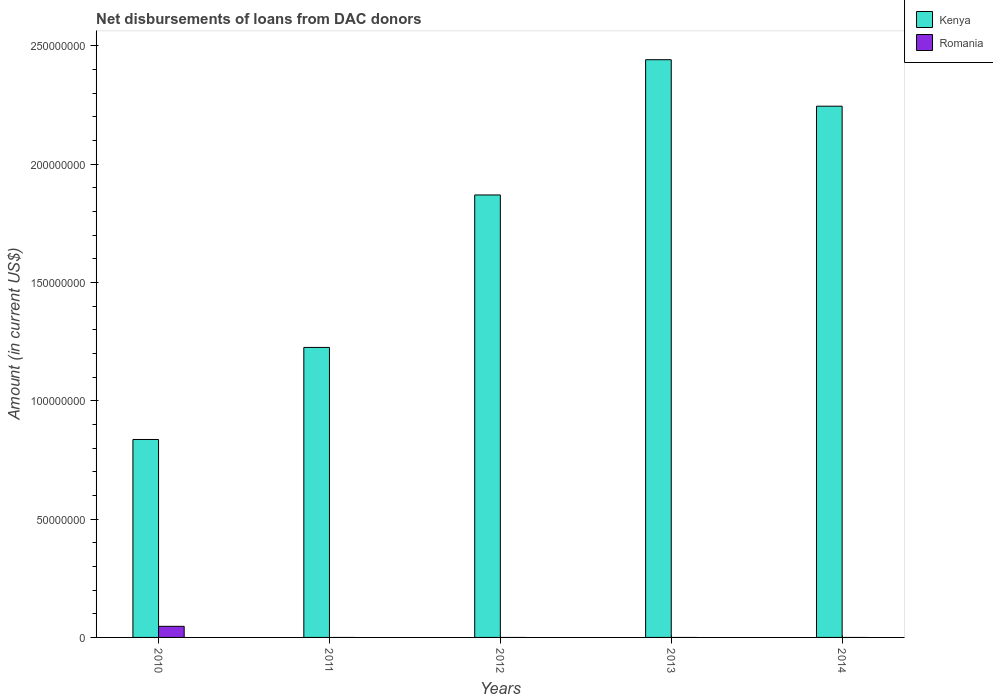How many different coloured bars are there?
Offer a terse response. 2. Are the number of bars per tick equal to the number of legend labels?
Keep it short and to the point. No. How many bars are there on the 5th tick from the left?
Offer a terse response. 1. How many bars are there on the 5th tick from the right?
Offer a terse response. 2. In how many cases, is the number of bars for a given year not equal to the number of legend labels?
Your answer should be compact. 4. Across all years, what is the maximum amount of loans disbursed in Romania?
Your response must be concise. 4.69e+06. Across all years, what is the minimum amount of loans disbursed in Kenya?
Ensure brevity in your answer.  8.37e+07. In which year was the amount of loans disbursed in Romania maximum?
Provide a short and direct response. 2010. What is the total amount of loans disbursed in Romania in the graph?
Give a very brief answer. 4.69e+06. What is the difference between the amount of loans disbursed in Kenya in 2011 and that in 2014?
Your answer should be very brief. -1.02e+08. What is the difference between the amount of loans disbursed in Kenya in 2011 and the amount of loans disbursed in Romania in 2010?
Ensure brevity in your answer.  1.18e+08. What is the average amount of loans disbursed in Kenya per year?
Ensure brevity in your answer.  1.72e+08. In the year 2010, what is the difference between the amount of loans disbursed in Romania and amount of loans disbursed in Kenya?
Provide a succinct answer. -7.90e+07. In how many years, is the amount of loans disbursed in Romania greater than 100000000 US$?
Provide a short and direct response. 0. What is the ratio of the amount of loans disbursed in Kenya in 2012 to that in 2013?
Your response must be concise. 0.77. Is the amount of loans disbursed in Kenya in 2011 less than that in 2014?
Provide a short and direct response. Yes. What is the difference between the highest and the second highest amount of loans disbursed in Kenya?
Your answer should be very brief. 1.96e+07. What is the difference between the highest and the lowest amount of loans disbursed in Romania?
Ensure brevity in your answer.  4.69e+06. In how many years, is the amount of loans disbursed in Romania greater than the average amount of loans disbursed in Romania taken over all years?
Your response must be concise. 1. How many bars are there?
Offer a terse response. 6. Are all the bars in the graph horizontal?
Keep it short and to the point. No. How many years are there in the graph?
Offer a terse response. 5. What is the difference between two consecutive major ticks on the Y-axis?
Your answer should be compact. 5.00e+07. Does the graph contain any zero values?
Your answer should be very brief. Yes. Does the graph contain grids?
Provide a succinct answer. No. How many legend labels are there?
Ensure brevity in your answer.  2. How are the legend labels stacked?
Ensure brevity in your answer.  Vertical. What is the title of the graph?
Make the answer very short. Net disbursements of loans from DAC donors. What is the label or title of the Y-axis?
Make the answer very short. Amount (in current US$). What is the Amount (in current US$) in Kenya in 2010?
Give a very brief answer. 8.37e+07. What is the Amount (in current US$) of Romania in 2010?
Offer a very short reply. 4.69e+06. What is the Amount (in current US$) in Kenya in 2011?
Keep it short and to the point. 1.23e+08. What is the Amount (in current US$) in Kenya in 2012?
Offer a very short reply. 1.87e+08. What is the Amount (in current US$) in Kenya in 2013?
Keep it short and to the point. 2.44e+08. What is the Amount (in current US$) in Kenya in 2014?
Ensure brevity in your answer.  2.25e+08. What is the Amount (in current US$) of Romania in 2014?
Provide a short and direct response. 0. Across all years, what is the maximum Amount (in current US$) of Kenya?
Make the answer very short. 2.44e+08. Across all years, what is the maximum Amount (in current US$) of Romania?
Provide a succinct answer. 4.69e+06. Across all years, what is the minimum Amount (in current US$) of Kenya?
Keep it short and to the point. 8.37e+07. What is the total Amount (in current US$) of Kenya in the graph?
Your answer should be very brief. 8.62e+08. What is the total Amount (in current US$) in Romania in the graph?
Ensure brevity in your answer.  4.69e+06. What is the difference between the Amount (in current US$) in Kenya in 2010 and that in 2011?
Keep it short and to the point. -3.89e+07. What is the difference between the Amount (in current US$) in Kenya in 2010 and that in 2012?
Ensure brevity in your answer.  -1.03e+08. What is the difference between the Amount (in current US$) in Kenya in 2010 and that in 2013?
Give a very brief answer. -1.61e+08. What is the difference between the Amount (in current US$) in Kenya in 2010 and that in 2014?
Keep it short and to the point. -1.41e+08. What is the difference between the Amount (in current US$) of Kenya in 2011 and that in 2012?
Offer a terse response. -6.44e+07. What is the difference between the Amount (in current US$) of Kenya in 2011 and that in 2013?
Provide a succinct answer. -1.22e+08. What is the difference between the Amount (in current US$) in Kenya in 2011 and that in 2014?
Your answer should be compact. -1.02e+08. What is the difference between the Amount (in current US$) of Kenya in 2012 and that in 2013?
Offer a terse response. -5.72e+07. What is the difference between the Amount (in current US$) of Kenya in 2012 and that in 2014?
Offer a very short reply. -3.75e+07. What is the difference between the Amount (in current US$) of Kenya in 2013 and that in 2014?
Offer a terse response. 1.96e+07. What is the average Amount (in current US$) of Kenya per year?
Give a very brief answer. 1.72e+08. What is the average Amount (in current US$) of Romania per year?
Ensure brevity in your answer.  9.38e+05. In the year 2010, what is the difference between the Amount (in current US$) in Kenya and Amount (in current US$) in Romania?
Ensure brevity in your answer.  7.90e+07. What is the ratio of the Amount (in current US$) in Kenya in 2010 to that in 2011?
Provide a short and direct response. 0.68. What is the ratio of the Amount (in current US$) in Kenya in 2010 to that in 2012?
Keep it short and to the point. 0.45. What is the ratio of the Amount (in current US$) of Kenya in 2010 to that in 2013?
Make the answer very short. 0.34. What is the ratio of the Amount (in current US$) in Kenya in 2010 to that in 2014?
Your response must be concise. 0.37. What is the ratio of the Amount (in current US$) in Kenya in 2011 to that in 2012?
Make the answer very short. 0.66. What is the ratio of the Amount (in current US$) of Kenya in 2011 to that in 2013?
Your response must be concise. 0.5. What is the ratio of the Amount (in current US$) in Kenya in 2011 to that in 2014?
Offer a very short reply. 0.55. What is the ratio of the Amount (in current US$) in Kenya in 2012 to that in 2013?
Your answer should be very brief. 0.77. What is the ratio of the Amount (in current US$) of Kenya in 2012 to that in 2014?
Ensure brevity in your answer.  0.83. What is the ratio of the Amount (in current US$) in Kenya in 2013 to that in 2014?
Your answer should be very brief. 1.09. What is the difference between the highest and the second highest Amount (in current US$) in Kenya?
Provide a short and direct response. 1.96e+07. What is the difference between the highest and the lowest Amount (in current US$) in Kenya?
Offer a terse response. 1.61e+08. What is the difference between the highest and the lowest Amount (in current US$) in Romania?
Provide a succinct answer. 4.69e+06. 